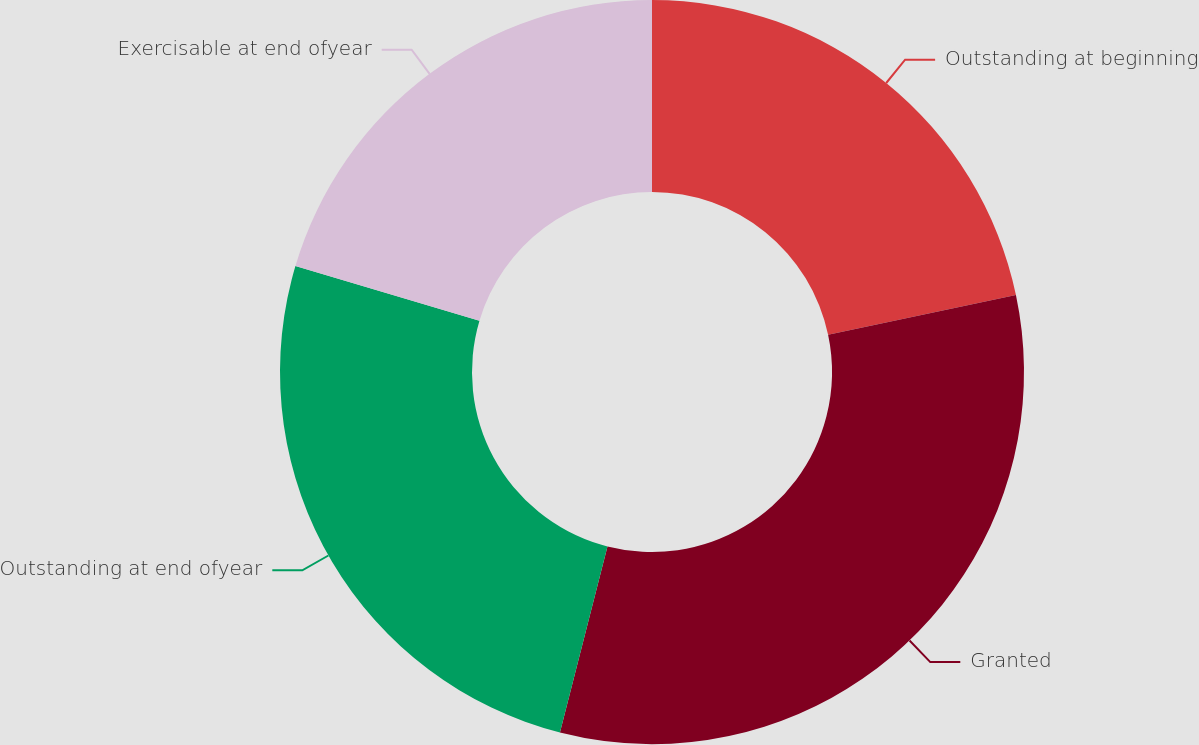<chart> <loc_0><loc_0><loc_500><loc_500><pie_chart><fcel>Outstanding at beginning<fcel>Granted<fcel>Outstanding at end ofyear<fcel>Exercisable at end ofyear<nl><fcel>21.68%<fcel>32.3%<fcel>25.62%<fcel>20.4%<nl></chart> 